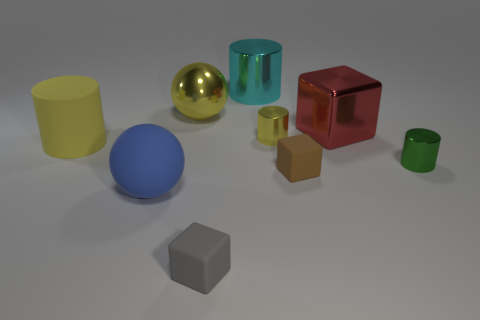Add 1 brown things. How many objects exist? 10 Subtract all cubes. How many objects are left? 6 Add 8 blue matte balls. How many blue matte balls are left? 9 Add 3 big blue rubber objects. How many big blue rubber objects exist? 4 Subtract 1 yellow balls. How many objects are left? 8 Subtract all small brown matte blocks. Subtract all yellow matte cylinders. How many objects are left? 7 